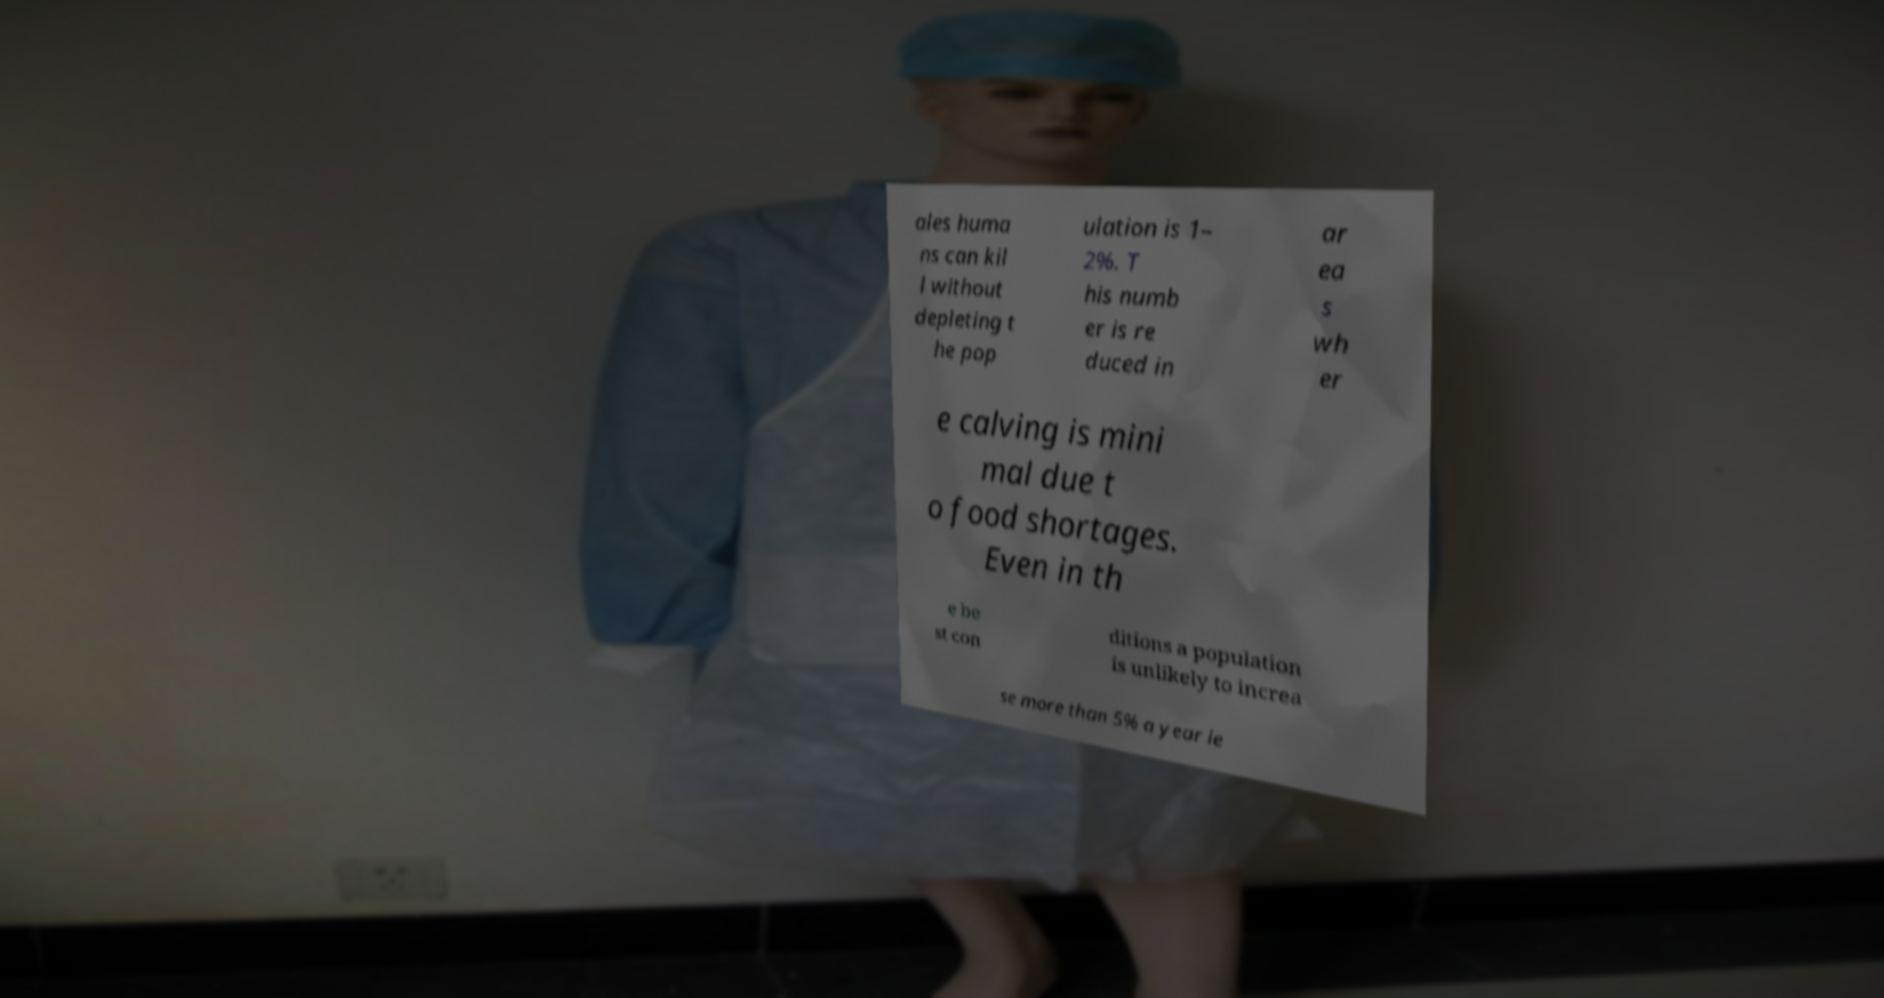What messages or text are displayed in this image? I need them in a readable, typed format. ales huma ns can kil l without depleting t he pop ulation is 1– 2%. T his numb er is re duced in ar ea s wh er e calving is mini mal due t o food shortages. Even in th e be st con ditions a population is unlikely to increa se more than 5% a year le 